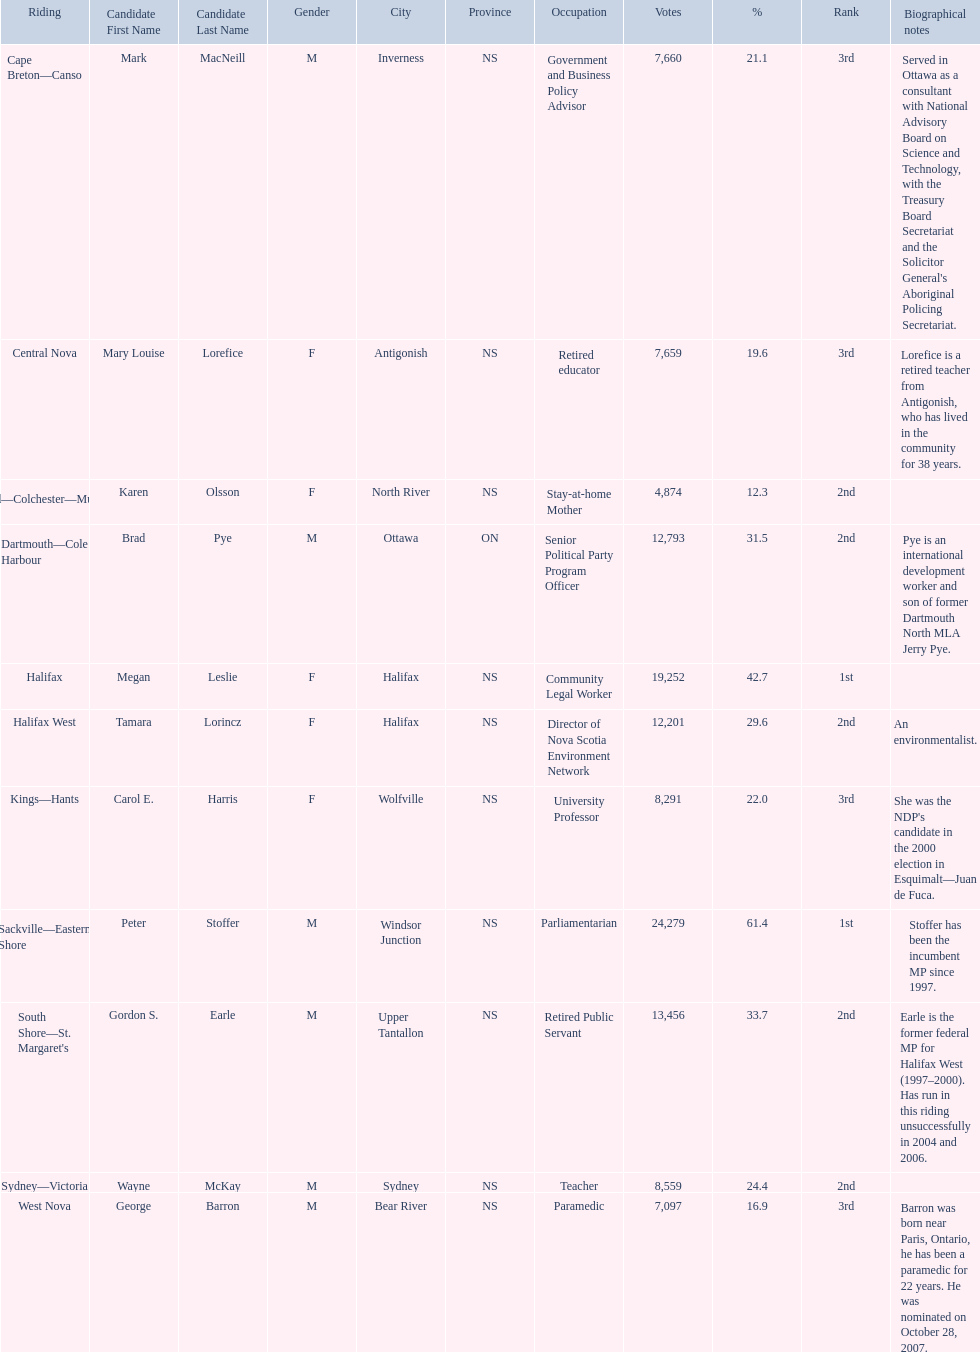Which candidates have the four lowest amount of votes Mark MacNeill, Mary Louise Lorefice, Karen Olsson, George Barron. Out of the following, who has the third most? Mark MacNeill. 